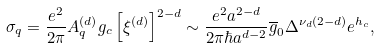<formula> <loc_0><loc_0><loc_500><loc_500>\sigma _ { q } = \frac { e ^ { 2 } } { 2 \pi } A ^ { ( d ) } _ { q } g _ { c } \left [ \xi ^ { ( d ) } \right ] ^ { 2 - d } \sim \frac { e ^ { 2 } a ^ { 2 - d } } { 2 \pi \hbar { a } ^ { d - 2 } } \overline { g } _ { 0 } \Delta ^ { \nu _ { d } ( 2 - d ) } e ^ { h _ { c } } ,</formula> 